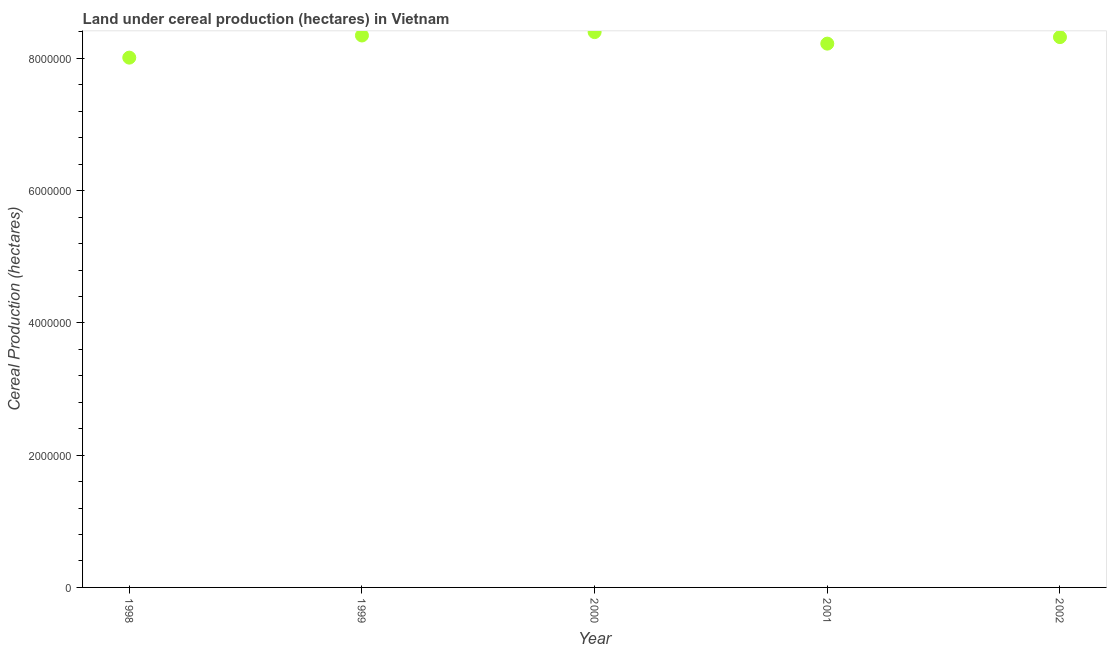What is the land under cereal production in 2001?
Give a very brief answer. 8.22e+06. Across all years, what is the maximum land under cereal production?
Provide a succinct answer. 8.40e+06. Across all years, what is the minimum land under cereal production?
Your response must be concise. 8.01e+06. What is the sum of the land under cereal production?
Provide a succinct answer. 4.13e+07. What is the difference between the land under cereal production in 2000 and 2001?
Your answer should be compact. 1.74e+05. What is the average land under cereal production per year?
Offer a very short reply. 8.26e+06. What is the median land under cereal production?
Ensure brevity in your answer.  8.32e+06. Do a majority of the years between 2001 and 2000 (inclusive) have land under cereal production greater than 6800000 hectares?
Ensure brevity in your answer.  No. What is the ratio of the land under cereal production in 1999 to that in 2001?
Give a very brief answer. 1.01. Is the land under cereal production in 1998 less than that in 2000?
Ensure brevity in your answer.  Yes. Is the difference between the land under cereal production in 2000 and 2002 greater than the difference between any two years?
Your answer should be very brief. No. What is the difference between the highest and the second highest land under cereal production?
Provide a succinct answer. 5.11e+04. What is the difference between the highest and the lowest land under cereal production?
Give a very brief answer. 3.86e+05. In how many years, is the land under cereal production greater than the average land under cereal production taken over all years?
Keep it short and to the point. 3. How many dotlines are there?
Ensure brevity in your answer.  1. Are the values on the major ticks of Y-axis written in scientific E-notation?
Give a very brief answer. No. Does the graph contain any zero values?
Provide a short and direct response. No. Does the graph contain grids?
Offer a terse response. No. What is the title of the graph?
Give a very brief answer. Land under cereal production (hectares) in Vietnam. What is the label or title of the X-axis?
Provide a short and direct response. Year. What is the label or title of the Y-axis?
Provide a succinct answer. Cereal Production (hectares). What is the Cereal Production (hectares) in 1998?
Give a very brief answer. 8.01e+06. What is the Cereal Production (hectares) in 1999?
Make the answer very short. 8.35e+06. What is the Cereal Production (hectares) in 2000?
Offer a terse response. 8.40e+06. What is the Cereal Production (hectares) in 2001?
Keep it short and to the point. 8.22e+06. What is the Cereal Production (hectares) in 2002?
Give a very brief answer. 8.32e+06. What is the difference between the Cereal Production (hectares) in 1998 and 1999?
Your response must be concise. -3.35e+05. What is the difference between the Cereal Production (hectares) in 1998 and 2000?
Provide a short and direct response. -3.86e+05. What is the difference between the Cereal Production (hectares) in 1998 and 2001?
Make the answer very short. -2.12e+05. What is the difference between the Cereal Production (hectares) in 1998 and 2002?
Keep it short and to the point. -3.10e+05. What is the difference between the Cereal Production (hectares) in 1999 and 2000?
Keep it short and to the point. -5.11e+04. What is the difference between the Cereal Production (hectares) in 1999 and 2001?
Ensure brevity in your answer.  1.23e+05. What is the difference between the Cereal Production (hectares) in 1999 and 2002?
Offer a very short reply. 2.47e+04. What is the difference between the Cereal Production (hectares) in 2000 and 2001?
Your answer should be very brief. 1.74e+05. What is the difference between the Cereal Production (hectares) in 2000 and 2002?
Provide a succinct answer. 7.58e+04. What is the difference between the Cereal Production (hectares) in 2001 and 2002?
Keep it short and to the point. -9.85e+04. What is the ratio of the Cereal Production (hectares) in 1998 to that in 2000?
Keep it short and to the point. 0.95. What is the ratio of the Cereal Production (hectares) in 1998 to that in 2001?
Provide a short and direct response. 0.97. What is the ratio of the Cereal Production (hectares) in 1998 to that in 2002?
Provide a short and direct response. 0.96. What is the ratio of the Cereal Production (hectares) in 1999 to that in 2001?
Your answer should be very brief. 1.01. What is the ratio of the Cereal Production (hectares) in 2000 to that in 2001?
Your answer should be very brief. 1.02. 